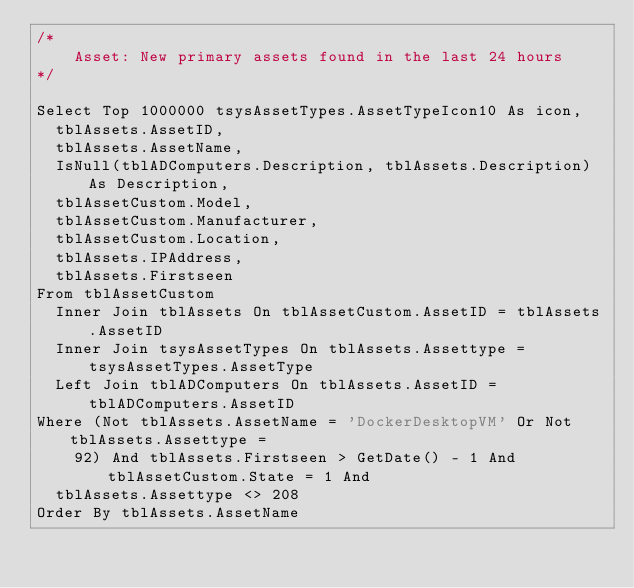<code> <loc_0><loc_0><loc_500><loc_500><_SQL_>/*
	Asset: New primary assets found in the last 24 hours
*/

Select Top 1000000 tsysAssetTypes.AssetTypeIcon10 As icon,
  tblAssets.AssetID,
  tblAssets.AssetName,
  IsNull(tblADComputers.Description, tblAssets.Description) As Description,
  tblAssetCustom.Model,
  tblAssetCustom.Manufacturer,
  tblAssetCustom.Location,
  tblAssets.IPAddress,
  tblAssets.Firstseen
From tblAssetCustom
  Inner Join tblAssets On tblAssetCustom.AssetID = tblAssets.AssetID
  Inner Join tsysAssetTypes On tblAssets.Assettype = tsysAssetTypes.AssetType
  Left Join tblADComputers On tblAssets.AssetID = tblADComputers.AssetID
Where (Not tblAssets.AssetName = 'DockerDesktopVM' Or Not tblAssets.Assettype =
    92) And tblAssets.Firstseen > GetDate() - 1 And tblAssetCustom.State = 1 And
  tblAssets.Assettype <> 208
Order By tblAssets.AssetName</code> 